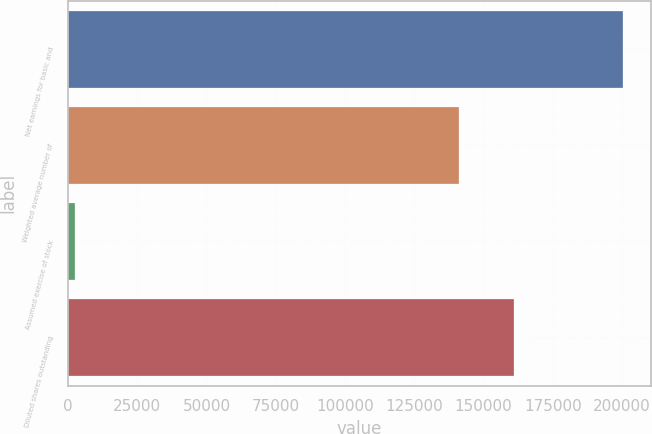<chart> <loc_0><loc_0><loc_500><loc_500><bar_chart><fcel>Net earnings for basic and<fcel>Weighted average number of<fcel>Assumed exercise of stock<fcel>Diluted shares outstanding<nl><fcel>200261<fcel>141143<fcel>2426<fcel>160926<nl></chart> 